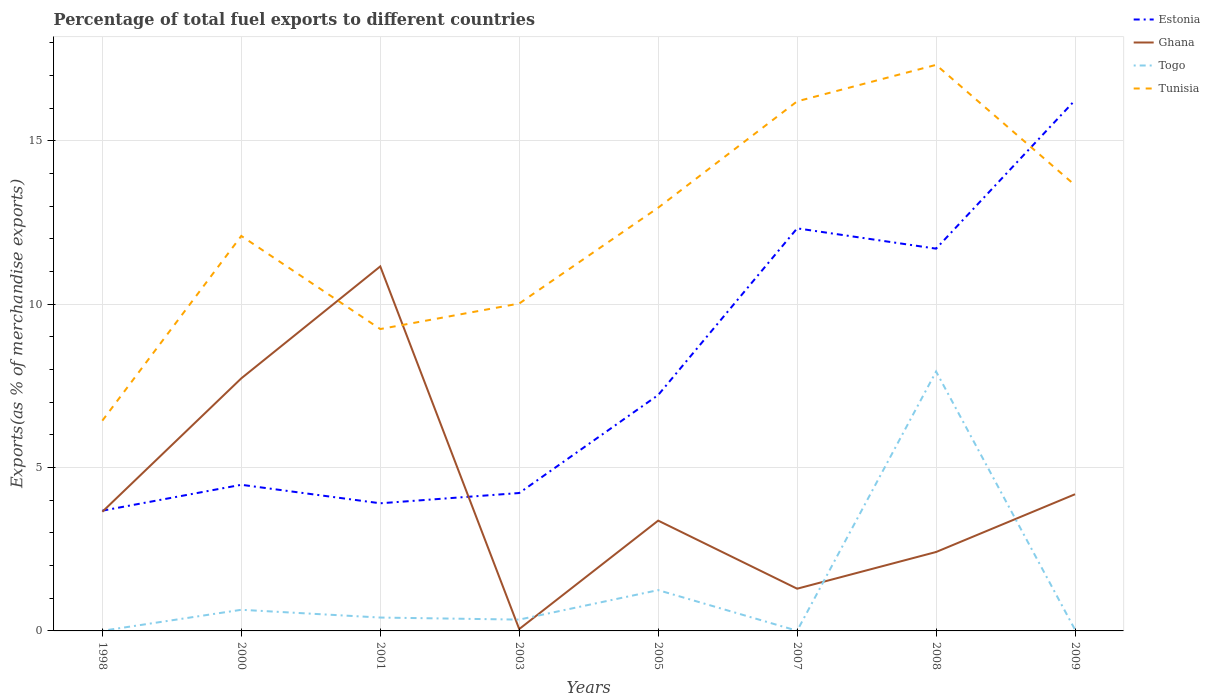How many different coloured lines are there?
Provide a succinct answer. 4. Is the number of lines equal to the number of legend labels?
Your response must be concise. Yes. Across all years, what is the maximum percentage of exports to different countries in Ghana?
Offer a terse response. 0.06. What is the total percentage of exports to different countries in Estonia in the graph?
Keep it short and to the point. -0.54. What is the difference between the highest and the second highest percentage of exports to different countries in Tunisia?
Ensure brevity in your answer.  10.89. What is the difference between the highest and the lowest percentage of exports to different countries in Ghana?
Your answer should be very brief. 2. Is the percentage of exports to different countries in Tunisia strictly greater than the percentage of exports to different countries in Ghana over the years?
Provide a short and direct response. No. How many lines are there?
Keep it short and to the point. 4. How many years are there in the graph?
Make the answer very short. 8. Does the graph contain any zero values?
Your answer should be very brief. No. Does the graph contain grids?
Provide a short and direct response. Yes. Where does the legend appear in the graph?
Offer a terse response. Top right. How many legend labels are there?
Ensure brevity in your answer.  4. How are the legend labels stacked?
Your response must be concise. Vertical. What is the title of the graph?
Your response must be concise. Percentage of total fuel exports to different countries. What is the label or title of the Y-axis?
Offer a very short reply. Exports(as % of merchandise exports). What is the Exports(as % of merchandise exports) in Estonia in 1998?
Provide a short and direct response. 3.68. What is the Exports(as % of merchandise exports) of Ghana in 1998?
Make the answer very short. 3.65. What is the Exports(as % of merchandise exports) in Togo in 1998?
Offer a terse response. 0. What is the Exports(as % of merchandise exports) of Tunisia in 1998?
Ensure brevity in your answer.  6.44. What is the Exports(as % of merchandise exports) in Estonia in 2000?
Offer a terse response. 4.47. What is the Exports(as % of merchandise exports) in Ghana in 2000?
Offer a terse response. 7.73. What is the Exports(as % of merchandise exports) in Togo in 2000?
Ensure brevity in your answer.  0.65. What is the Exports(as % of merchandise exports) of Tunisia in 2000?
Provide a short and direct response. 12.09. What is the Exports(as % of merchandise exports) of Estonia in 2001?
Make the answer very short. 3.91. What is the Exports(as % of merchandise exports) in Ghana in 2001?
Your response must be concise. 11.16. What is the Exports(as % of merchandise exports) of Togo in 2001?
Your answer should be very brief. 0.41. What is the Exports(as % of merchandise exports) in Tunisia in 2001?
Provide a succinct answer. 9.24. What is the Exports(as % of merchandise exports) of Estonia in 2003?
Make the answer very short. 4.22. What is the Exports(as % of merchandise exports) of Ghana in 2003?
Offer a very short reply. 0.06. What is the Exports(as % of merchandise exports) in Togo in 2003?
Keep it short and to the point. 0.35. What is the Exports(as % of merchandise exports) of Tunisia in 2003?
Keep it short and to the point. 10.02. What is the Exports(as % of merchandise exports) in Estonia in 2005?
Your answer should be compact. 7.22. What is the Exports(as % of merchandise exports) in Ghana in 2005?
Ensure brevity in your answer.  3.38. What is the Exports(as % of merchandise exports) in Togo in 2005?
Offer a terse response. 1.25. What is the Exports(as % of merchandise exports) in Tunisia in 2005?
Provide a short and direct response. 12.95. What is the Exports(as % of merchandise exports) in Estonia in 2007?
Provide a short and direct response. 12.32. What is the Exports(as % of merchandise exports) of Ghana in 2007?
Ensure brevity in your answer.  1.29. What is the Exports(as % of merchandise exports) of Togo in 2007?
Provide a short and direct response. 0. What is the Exports(as % of merchandise exports) in Tunisia in 2007?
Ensure brevity in your answer.  16.21. What is the Exports(as % of merchandise exports) in Estonia in 2008?
Offer a very short reply. 11.7. What is the Exports(as % of merchandise exports) of Ghana in 2008?
Your answer should be compact. 2.42. What is the Exports(as % of merchandise exports) in Togo in 2008?
Keep it short and to the point. 7.94. What is the Exports(as % of merchandise exports) in Tunisia in 2008?
Offer a terse response. 17.32. What is the Exports(as % of merchandise exports) of Estonia in 2009?
Provide a succinct answer. 16.24. What is the Exports(as % of merchandise exports) of Ghana in 2009?
Provide a short and direct response. 4.18. What is the Exports(as % of merchandise exports) in Togo in 2009?
Your answer should be compact. 0.04. What is the Exports(as % of merchandise exports) in Tunisia in 2009?
Keep it short and to the point. 13.64. Across all years, what is the maximum Exports(as % of merchandise exports) of Estonia?
Offer a very short reply. 16.24. Across all years, what is the maximum Exports(as % of merchandise exports) of Ghana?
Your answer should be very brief. 11.16. Across all years, what is the maximum Exports(as % of merchandise exports) in Togo?
Ensure brevity in your answer.  7.94. Across all years, what is the maximum Exports(as % of merchandise exports) in Tunisia?
Provide a succinct answer. 17.32. Across all years, what is the minimum Exports(as % of merchandise exports) of Estonia?
Your answer should be very brief. 3.68. Across all years, what is the minimum Exports(as % of merchandise exports) in Ghana?
Keep it short and to the point. 0.06. Across all years, what is the minimum Exports(as % of merchandise exports) in Togo?
Ensure brevity in your answer.  0. Across all years, what is the minimum Exports(as % of merchandise exports) of Tunisia?
Your answer should be very brief. 6.44. What is the total Exports(as % of merchandise exports) in Estonia in the graph?
Make the answer very short. 63.76. What is the total Exports(as % of merchandise exports) in Ghana in the graph?
Provide a short and direct response. 33.86. What is the total Exports(as % of merchandise exports) in Togo in the graph?
Offer a very short reply. 10.63. What is the total Exports(as % of merchandise exports) of Tunisia in the graph?
Make the answer very short. 97.91. What is the difference between the Exports(as % of merchandise exports) of Estonia in 1998 and that in 2000?
Your response must be concise. -0.79. What is the difference between the Exports(as % of merchandise exports) of Ghana in 1998 and that in 2000?
Keep it short and to the point. -4.08. What is the difference between the Exports(as % of merchandise exports) of Togo in 1998 and that in 2000?
Your answer should be very brief. -0.64. What is the difference between the Exports(as % of merchandise exports) in Tunisia in 1998 and that in 2000?
Your response must be concise. -5.65. What is the difference between the Exports(as % of merchandise exports) of Estonia in 1998 and that in 2001?
Your answer should be very brief. -0.23. What is the difference between the Exports(as % of merchandise exports) of Ghana in 1998 and that in 2001?
Ensure brevity in your answer.  -7.51. What is the difference between the Exports(as % of merchandise exports) of Togo in 1998 and that in 2001?
Provide a succinct answer. -0.41. What is the difference between the Exports(as % of merchandise exports) in Tunisia in 1998 and that in 2001?
Your response must be concise. -2.8. What is the difference between the Exports(as % of merchandise exports) in Estonia in 1998 and that in 2003?
Offer a terse response. -0.54. What is the difference between the Exports(as % of merchandise exports) of Ghana in 1998 and that in 2003?
Provide a succinct answer. 3.59. What is the difference between the Exports(as % of merchandise exports) in Togo in 1998 and that in 2003?
Your answer should be very brief. -0.34. What is the difference between the Exports(as % of merchandise exports) in Tunisia in 1998 and that in 2003?
Your answer should be very brief. -3.58. What is the difference between the Exports(as % of merchandise exports) in Estonia in 1998 and that in 2005?
Provide a short and direct response. -3.54. What is the difference between the Exports(as % of merchandise exports) of Ghana in 1998 and that in 2005?
Make the answer very short. 0.27. What is the difference between the Exports(as % of merchandise exports) of Togo in 1998 and that in 2005?
Your response must be concise. -1.24. What is the difference between the Exports(as % of merchandise exports) in Tunisia in 1998 and that in 2005?
Provide a succinct answer. -6.52. What is the difference between the Exports(as % of merchandise exports) of Estonia in 1998 and that in 2007?
Offer a very short reply. -8.64. What is the difference between the Exports(as % of merchandise exports) in Ghana in 1998 and that in 2007?
Provide a succinct answer. 2.35. What is the difference between the Exports(as % of merchandise exports) of Togo in 1998 and that in 2007?
Your response must be concise. -0. What is the difference between the Exports(as % of merchandise exports) of Tunisia in 1998 and that in 2007?
Make the answer very short. -9.77. What is the difference between the Exports(as % of merchandise exports) in Estonia in 1998 and that in 2008?
Offer a terse response. -8.02. What is the difference between the Exports(as % of merchandise exports) in Ghana in 1998 and that in 2008?
Offer a terse response. 1.23. What is the difference between the Exports(as % of merchandise exports) in Togo in 1998 and that in 2008?
Provide a succinct answer. -7.93. What is the difference between the Exports(as % of merchandise exports) in Tunisia in 1998 and that in 2008?
Ensure brevity in your answer.  -10.89. What is the difference between the Exports(as % of merchandise exports) in Estonia in 1998 and that in 2009?
Ensure brevity in your answer.  -12.56. What is the difference between the Exports(as % of merchandise exports) of Ghana in 1998 and that in 2009?
Offer a terse response. -0.54. What is the difference between the Exports(as % of merchandise exports) in Togo in 1998 and that in 2009?
Offer a very short reply. -0.03. What is the difference between the Exports(as % of merchandise exports) in Tunisia in 1998 and that in 2009?
Keep it short and to the point. -7.21. What is the difference between the Exports(as % of merchandise exports) in Estonia in 2000 and that in 2001?
Your response must be concise. 0.57. What is the difference between the Exports(as % of merchandise exports) in Ghana in 2000 and that in 2001?
Ensure brevity in your answer.  -3.43. What is the difference between the Exports(as % of merchandise exports) of Togo in 2000 and that in 2001?
Keep it short and to the point. 0.24. What is the difference between the Exports(as % of merchandise exports) in Tunisia in 2000 and that in 2001?
Offer a very short reply. 2.85. What is the difference between the Exports(as % of merchandise exports) in Estonia in 2000 and that in 2003?
Provide a short and direct response. 0.25. What is the difference between the Exports(as % of merchandise exports) in Ghana in 2000 and that in 2003?
Provide a short and direct response. 7.67. What is the difference between the Exports(as % of merchandise exports) of Togo in 2000 and that in 2003?
Give a very brief answer. 0.3. What is the difference between the Exports(as % of merchandise exports) of Tunisia in 2000 and that in 2003?
Ensure brevity in your answer.  2.07. What is the difference between the Exports(as % of merchandise exports) in Estonia in 2000 and that in 2005?
Give a very brief answer. -2.75. What is the difference between the Exports(as % of merchandise exports) of Ghana in 2000 and that in 2005?
Provide a succinct answer. 4.35. What is the difference between the Exports(as % of merchandise exports) in Togo in 2000 and that in 2005?
Provide a succinct answer. -0.6. What is the difference between the Exports(as % of merchandise exports) in Tunisia in 2000 and that in 2005?
Keep it short and to the point. -0.86. What is the difference between the Exports(as % of merchandise exports) of Estonia in 2000 and that in 2007?
Ensure brevity in your answer.  -7.85. What is the difference between the Exports(as % of merchandise exports) in Ghana in 2000 and that in 2007?
Make the answer very short. 6.44. What is the difference between the Exports(as % of merchandise exports) of Togo in 2000 and that in 2007?
Offer a very short reply. 0.64. What is the difference between the Exports(as % of merchandise exports) in Tunisia in 2000 and that in 2007?
Your response must be concise. -4.12. What is the difference between the Exports(as % of merchandise exports) in Estonia in 2000 and that in 2008?
Provide a short and direct response. -7.23. What is the difference between the Exports(as % of merchandise exports) of Ghana in 2000 and that in 2008?
Make the answer very short. 5.31. What is the difference between the Exports(as % of merchandise exports) of Togo in 2000 and that in 2008?
Offer a terse response. -7.29. What is the difference between the Exports(as % of merchandise exports) of Tunisia in 2000 and that in 2008?
Keep it short and to the point. -5.24. What is the difference between the Exports(as % of merchandise exports) of Estonia in 2000 and that in 2009?
Keep it short and to the point. -11.77. What is the difference between the Exports(as % of merchandise exports) in Ghana in 2000 and that in 2009?
Keep it short and to the point. 3.55. What is the difference between the Exports(as % of merchandise exports) of Togo in 2000 and that in 2009?
Offer a terse response. 0.61. What is the difference between the Exports(as % of merchandise exports) in Tunisia in 2000 and that in 2009?
Provide a short and direct response. -1.55. What is the difference between the Exports(as % of merchandise exports) in Estonia in 2001 and that in 2003?
Provide a short and direct response. -0.31. What is the difference between the Exports(as % of merchandise exports) of Ghana in 2001 and that in 2003?
Ensure brevity in your answer.  11.1. What is the difference between the Exports(as % of merchandise exports) in Togo in 2001 and that in 2003?
Provide a short and direct response. 0.06. What is the difference between the Exports(as % of merchandise exports) in Tunisia in 2001 and that in 2003?
Make the answer very short. -0.78. What is the difference between the Exports(as % of merchandise exports) of Estonia in 2001 and that in 2005?
Offer a terse response. -3.31. What is the difference between the Exports(as % of merchandise exports) in Ghana in 2001 and that in 2005?
Provide a short and direct response. 7.78. What is the difference between the Exports(as % of merchandise exports) in Togo in 2001 and that in 2005?
Keep it short and to the point. -0.84. What is the difference between the Exports(as % of merchandise exports) in Tunisia in 2001 and that in 2005?
Offer a terse response. -3.71. What is the difference between the Exports(as % of merchandise exports) of Estonia in 2001 and that in 2007?
Keep it short and to the point. -8.41. What is the difference between the Exports(as % of merchandise exports) in Ghana in 2001 and that in 2007?
Keep it short and to the point. 9.86. What is the difference between the Exports(as % of merchandise exports) of Togo in 2001 and that in 2007?
Give a very brief answer. 0.4. What is the difference between the Exports(as % of merchandise exports) of Tunisia in 2001 and that in 2007?
Keep it short and to the point. -6.97. What is the difference between the Exports(as % of merchandise exports) of Estonia in 2001 and that in 2008?
Your answer should be very brief. -7.79. What is the difference between the Exports(as % of merchandise exports) of Ghana in 2001 and that in 2008?
Make the answer very short. 8.74. What is the difference between the Exports(as % of merchandise exports) in Togo in 2001 and that in 2008?
Provide a short and direct response. -7.53. What is the difference between the Exports(as % of merchandise exports) of Tunisia in 2001 and that in 2008?
Your answer should be compact. -8.09. What is the difference between the Exports(as % of merchandise exports) of Estonia in 2001 and that in 2009?
Ensure brevity in your answer.  -12.34. What is the difference between the Exports(as % of merchandise exports) in Ghana in 2001 and that in 2009?
Your answer should be compact. 6.97. What is the difference between the Exports(as % of merchandise exports) in Togo in 2001 and that in 2009?
Offer a terse response. 0.37. What is the difference between the Exports(as % of merchandise exports) of Tunisia in 2001 and that in 2009?
Provide a succinct answer. -4.4. What is the difference between the Exports(as % of merchandise exports) in Estonia in 2003 and that in 2005?
Make the answer very short. -3. What is the difference between the Exports(as % of merchandise exports) in Ghana in 2003 and that in 2005?
Your response must be concise. -3.32. What is the difference between the Exports(as % of merchandise exports) in Togo in 2003 and that in 2005?
Your response must be concise. -0.9. What is the difference between the Exports(as % of merchandise exports) in Tunisia in 2003 and that in 2005?
Your answer should be compact. -2.93. What is the difference between the Exports(as % of merchandise exports) of Estonia in 2003 and that in 2007?
Ensure brevity in your answer.  -8.1. What is the difference between the Exports(as % of merchandise exports) of Ghana in 2003 and that in 2007?
Your answer should be very brief. -1.24. What is the difference between the Exports(as % of merchandise exports) in Togo in 2003 and that in 2007?
Offer a terse response. 0.34. What is the difference between the Exports(as % of merchandise exports) of Tunisia in 2003 and that in 2007?
Give a very brief answer. -6.19. What is the difference between the Exports(as % of merchandise exports) of Estonia in 2003 and that in 2008?
Offer a terse response. -7.48. What is the difference between the Exports(as % of merchandise exports) in Ghana in 2003 and that in 2008?
Provide a short and direct response. -2.36. What is the difference between the Exports(as % of merchandise exports) of Togo in 2003 and that in 2008?
Provide a short and direct response. -7.59. What is the difference between the Exports(as % of merchandise exports) in Tunisia in 2003 and that in 2008?
Provide a succinct answer. -7.3. What is the difference between the Exports(as % of merchandise exports) of Estonia in 2003 and that in 2009?
Your response must be concise. -12.02. What is the difference between the Exports(as % of merchandise exports) of Ghana in 2003 and that in 2009?
Your answer should be compact. -4.13. What is the difference between the Exports(as % of merchandise exports) in Togo in 2003 and that in 2009?
Provide a succinct answer. 0.31. What is the difference between the Exports(as % of merchandise exports) of Tunisia in 2003 and that in 2009?
Ensure brevity in your answer.  -3.62. What is the difference between the Exports(as % of merchandise exports) in Estonia in 2005 and that in 2007?
Your response must be concise. -5.1. What is the difference between the Exports(as % of merchandise exports) of Ghana in 2005 and that in 2007?
Provide a short and direct response. 2.08. What is the difference between the Exports(as % of merchandise exports) in Togo in 2005 and that in 2007?
Offer a terse response. 1.24. What is the difference between the Exports(as % of merchandise exports) in Tunisia in 2005 and that in 2007?
Your answer should be compact. -3.26. What is the difference between the Exports(as % of merchandise exports) of Estonia in 2005 and that in 2008?
Give a very brief answer. -4.48. What is the difference between the Exports(as % of merchandise exports) in Ghana in 2005 and that in 2008?
Provide a short and direct response. 0.96. What is the difference between the Exports(as % of merchandise exports) in Togo in 2005 and that in 2008?
Ensure brevity in your answer.  -6.69. What is the difference between the Exports(as % of merchandise exports) of Tunisia in 2005 and that in 2008?
Keep it short and to the point. -4.37. What is the difference between the Exports(as % of merchandise exports) in Estonia in 2005 and that in 2009?
Your answer should be compact. -9.02. What is the difference between the Exports(as % of merchandise exports) of Ghana in 2005 and that in 2009?
Provide a succinct answer. -0.81. What is the difference between the Exports(as % of merchandise exports) in Togo in 2005 and that in 2009?
Keep it short and to the point. 1.21. What is the difference between the Exports(as % of merchandise exports) of Tunisia in 2005 and that in 2009?
Give a very brief answer. -0.69. What is the difference between the Exports(as % of merchandise exports) in Estonia in 2007 and that in 2008?
Keep it short and to the point. 0.62. What is the difference between the Exports(as % of merchandise exports) in Ghana in 2007 and that in 2008?
Ensure brevity in your answer.  -1.12. What is the difference between the Exports(as % of merchandise exports) in Togo in 2007 and that in 2008?
Ensure brevity in your answer.  -7.93. What is the difference between the Exports(as % of merchandise exports) of Tunisia in 2007 and that in 2008?
Your response must be concise. -1.12. What is the difference between the Exports(as % of merchandise exports) in Estonia in 2007 and that in 2009?
Make the answer very short. -3.92. What is the difference between the Exports(as % of merchandise exports) of Ghana in 2007 and that in 2009?
Make the answer very short. -2.89. What is the difference between the Exports(as % of merchandise exports) of Togo in 2007 and that in 2009?
Provide a short and direct response. -0.03. What is the difference between the Exports(as % of merchandise exports) of Tunisia in 2007 and that in 2009?
Make the answer very short. 2.57. What is the difference between the Exports(as % of merchandise exports) in Estonia in 2008 and that in 2009?
Offer a terse response. -4.54. What is the difference between the Exports(as % of merchandise exports) of Ghana in 2008 and that in 2009?
Make the answer very short. -1.77. What is the difference between the Exports(as % of merchandise exports) of Togo in 2008 and that in 2009?
Your response must be concise. 7.9. What is the difference between the Exports(as % of merchandise exports) in Tunisia in 2008 and that in 2009?
Offer a very short reply. 3.68. What is the difference between the Exports(as % of merchandise exports) in Estonia in 1998 and the Exports(as % of merchandise exports) in Ghana in 2000?
Your answer should be compact. -4.05. What is the difference between the Exports(as % of merchandise exports) of Estonia in 1998 and the Exports(as % of merchandise exports) of Togo in 2000?
Provide a succinct answer. 3.03. What is the difference between the Exports(as % of merchandise exports) in Estonia in 1998 and the Exports(as % of merchandise exports) in Tunisia in 2000?
Provide a succinct answer. -8.41. What is the difference between the Exports(as % of merchandise exports) in Ghana in 1998 and the Exports(as % of merchandise exports) in Togo in 2000?
Your answer should be compact. 3. What is the difference between the Exports(as % of merchandise exports) of Ghana in 1998 and the Exports(as % of merchandise exports) of Tunisia in 2000?
Offer a very short reply. -8.44. What is the difference between the Exports(as % of merchandise exports) in Togo in 1998 and the Exports(as % of merchandise exports) in Tunisia in 2000?
Give a very brief answer. -12.08. What is the difference between the Exports(as % of merchandise exports) in Estonia in 1998 and the Exports(as % of merchandise exports) in Ghana in 2001?
Make the answer very short. -7.48. What is the difference between the Exports(as % of merchandise exports) in Estonia in 1998 and the Exports(as % of merchandise exports) in Togo in 2001?
Offer a very short reply. 3.27. What is the difference between the Exports(as % of merchandise exports) in Estonia in 1998 and the Exports(as % of merchandise exports) in Tunisia in 2001?
Your answer should be very brief. -5.56. What is the difference between the Exports(as % of merchandise exports) of Ghana in 1998 and the Exports(as % of merchandise exports) of Togo in 2001?
Give a very brief answer. 3.24. What is the difference between the Exports(as % of merchandise exports) in Ghana in 1998 and the Exports(as % of merchandise exports) in Tunisia in 2001?
Your answer should be very brief. -5.59. What is the difference between the Exports(as % of merchandise exports) in Togo in 1998 and the Exports(as % of merchandise exports) in Tunisia in 2001?
Give a very brief answer. -9.23. What is the difference between the Exports(as % of merchandise exports) of Estonia in 1998 and the Exports(as % of merchandise exports) of Ghana in 2003?
Keep it short and to the point. 3.62. What is the difference between the Exports(as % of merchandise exports) in Estonia in 1998 and the Exports(as % of merchandise exports) in Togo in 2003?
Give a very brief answer. 3.33. What is the difference between the Exports(as % of merchandise exports) of Estonia in 1998 and the Exports(as % of merchandise exports) of Tunisia in 2003?
Make the answer very short. -6.34. What is the difference between the Exports(as % of merchandise exports) in Ghana in 1998 and the Exports(as % of merchandise exports) in Togo in 2003?
Offer a terse response. 3.3. What is the difference between the Exports(as % of merchandise exports) in Ghana in 1998 and the Exports(as % of merchandise exports) in Tunisia in 2003?
Provide a short and direct response. -6.37. What is the difference between the Exports(as % of merchandise exports) in Togo in 1998 and the Exports(as % of merchandise exports) in Tunisia in 2003?
Provide a short and direct response. -10.02. What is the difference between the Exports(as % of merchandise exports) in Estonia in 1998 and the Exports(as % of merchandise exports) in Ghana in 2005?
Your answer should be compact. 0.3. What is the difference between the Exports(as % of merchandise exports) in Estonia in 1998 and the Exports(as % of merchandise exports) in Togo in 2005?
Keep it short and to the point. 2.43. What is the difference between the Exports(as % of merchandise exports) of Estonia in 1998 and the Exports(as % of merchandise exports) of Tunisia in 2005?
Offer a very short reply. -9.27. What is the difference between the Exports(as % of merchandise exports) in Ghana in 1998 and the Exports(as % of merchandise exports) in Togo in 2005?
Offer a very short reply. 2.4. What is the difference between the Exports(as % of merchandise exports) in Ghana in 1998 and the Exports(as % of merchandise exports) in Tunisia in 2005?
Your response must be concise. -9.31. What is the difference between the Exports(as % of merchandise exports) of Togo in 1998 and the Exports(as % of merchandise exports) of Tunisia in 2005?
Keep it short and to the point. -12.95. What is the difference between the Exports(as % of merchandise exports) in Estonia in 1998 and the Exports(as % of merchandise exports) in Ghana in 2007?
Keep it short and to the point. 2.39. What is the difference between the Exports(as % of merchandise exports) of Estonia in 1998 and the Exports(as % of merchandise exports) of Togo in 2007?
Provide a succinct answer. 3.68. What is the difference between the Exports(as % of merchandise exports) in Estonia in 1998 and the Exports(as % of merchandise exports) in Tunisia in 2007?
Your answer should be very brief. -12.53. What is the difference between the Exports(as % of merchandise exports) of Ghana in 1998 and the Exports(as % of merchandise exports) of Togo in 2007?
Offer a very short reply. 3.64. What is the difference between the Exports(as % of merchandise exports) of Ghana in 1998 and the Exports(as % of merchandise exports) of Tunisia in 2007?
Offer a terse response. -12.56. What is the difference between the Exports(as % of merchandise exports) in Togo in 1998 and the Exports(as % of merchandise exports) in Tunisia in 2007?
Give a very brief answer. -16.2. What is the difference between the Exports(as % of merchandise exports) of Estonia in 1998 and the Exports(as % of merchandise exports) of Ghana in 2008?
Keep it short and to the point. 1.26. What is the difference between the Exports(as % of merchandise exports) in Estonia in 1998 and the Exports(as % of merchandise exports) in Togo in 2008?
Provide a short and direct response. -4.26. What is the difference between the Exports(as % of merchandise exports) of Estonia in 1998 and the Exports(as % of merchandise exports) of Tunisia in 2008?
Provide a succinct answer. -13.64. What is the difference between the Exports(as % of merchandise exports) of Ghana in 1998 and the Exports(as % of merchandise exports) of Togo in 2008?
Your answer should be very brief. -4.29. What is the difference between the Exports(as % of merchandise exports) in Ghana in 1998 and the Exports(as % of merchandise exports) in Tunisia in 2008?
Your answer should be compact. -13.68. What is the difference between the Exports(as % of merchandise exports) in Togo in 1998 and the Exports(as % of merchandise exports) in Tunisia in 2008?
Ensure brevity in your answer.  -17.32. What is the difference between the Exports(as % of merchandise exports) in Estonia in 1998 and the Exports(as % of merchandise exports) in Ghana in 2009?
Your answer should be compact. -0.5. What is the difference between the Exports(as % of merchandise exports) of Estonia in 1998 and the Exports(as % of merchandise exports) of Togo in 2009?
Ensure brevity in your answer.  3.64. What is the difference between the Exports(as % of merchandise exports) of Estonia in 1998 and the Exports(as % of merchandise exports) of Tunisia in 2009?
Keep it short and to the point. -9.96. What is the difference between the Exports(as % of merchandise exports) of Ghana in 1998 and the Exports(as % of merchandise exports) of Togo in 2009?
Make the answer very short. 3.61. What is the difference between the Exports(as % of merchandise exports) of Ghana in 1998 and the Exports(as % of merchandise exports) of Tunisia in 2009?
Provide a succinct answer. -9.99. What is the difference between the Exports(as % of merchandise exports) in Togo in 1998 and the Exports(as % of merchandise exports) in Tunisia in 2009?
Your response must be concise. -13.64. What is the difference between the Exports(as % of merchandise exports) in Estonia in 2000 and the Exports(as % of merchandise exports) in Ghana in 2001?
Provide a succinct answer. -6.68. What is the difference between the Exports(as % of merchandise exports) in Estonia in 2000 and the Exports(as % of merchandise exports) in Togo in 2001?
Give a very brief answer. 4.06. What is the difference between the Exports(as % of merchandise exports) in Estonia in 2000 and the Exports(as % of merchandise exports) in Tunisia in 2001?
Provide a short and direct response. -4.77. What is the difference between the Exports(as % of merchandise exports) of Ghana in 2000 and the Exports(as % of merchandise exports) of Togo in 2001?
Provide a succinct answer. 7.32. What is the difference between the Exports(as % of merchandise exports) of Ghana in 2000 and the Exports(as % of merchandise exports) of Tunisia in 2001?
Ensure brevity in your answer.  -1.51. What is the difference between the Exports(as % of merchandise exports) in Togo in 2000 and the Exports(as % of merchandise exports) in Tunisia in 2001?
Make the answer very short. -8.59. What is the difference between the Exports(as % of merchandise exports) in Estonia in 2000 and the Exports(as % of merchandise exports) in Ghana in 2003?
Give a very brief answer. 4.42. What is the difference between the Exports(as % of merchandise exports) in Estonia in 2000 and the Exports(as % of merchandise exports) in Togo in 2003?
Your answer should be very brief. 4.13. What is the difference between the Exports(as % of merchandise exports) of Estonia in 2000 and the Exports(as % of merchandise exports) of Tunisia in 2003?
Your response must be concise. -5.55. What is the difference between the Exports(as % of merchandise exports) of Ghana in 2000 and the Exports(as % of merchandise exports) of Togo in 2003?
Your answer should be compact. 7.38. What is the difference between the Exports(as % of merchandise exports) in Ghana in 2000 and the Exports(as % of merchandise exports) in Tunisia in 2003?
Your response must be concise. -2.29. What is the difference between the Exports(as % of merchandise exports) of Togo in 2000 and the Exports(as % of merchandise exports) of Tunisia in 2003?
Make the answer very short. -9.37. What is the difference between the Exports(as % of merchandise exports) in Estonia in 2000 and the Exports(as % of merchandise exports) in Ghana in 2005?
Offer a very short reply. 1.1. What is the difference between the Exports(as % of merchandise exports) in Estonia in 2000 and the Exports(as % of merchandise exports) in Togo in 2005?
Your response must be concise. 3.22. What is the difference between the Exports(as % of merchandise exports) in Estonia in 2000 and the Exports(as % of merchandise exports) in Tunisia in 2005?
Provide a short and direct response. -8.48. What is the difference between the Exports(as % of merchandise exports) of Ghana in 2000 and the Exports(as % of merchandise exports) of Togo in 2005?
Your answer should be compact. 6.48. What is the difference between the Exports(as % of merchandise exports) of Ghana in 2000 and the Exports(as % of merchandise exports) of Tunisia in 2005?
Give a very brief answer. -5.22. What is the difference between the Exports(as % of merchandise exports) in Togo in 2000 and the Exports(as % of merchandise exports) in Tunisia in 2005?
Ensure brevity in your answer.  -12.31. What is the difference between the Exports(as % of merchandise exports) in Estonia in 2000 and the Exports(as % of merchandise exports) in Ghana in 2007?
Keep it short and to the point. 3.18. What is the difference between the Exports(as % of merchandise exports) of Estonia in 2000 and the Exports(as % of merchandise exports) of Togo in 2007?
Your answer should be very brief. 4.47. What is the difference between the Exports(as % of merchandise exports) of Estonia in 2000 and the Exports(as % of merchandise exports) of Tunisia in 2007?
Keep it short and to the point. -11.74. What is the difference between the Exports(as % of merchandise exports) of Ghana in 2000 and the Exports(as % of merchandise exports) of Togo in 2007?
Make the answer very short. 7.73. What is the difference between the Exports(as % of merchandise exports) in Ghana in 2000 and the Exports(as % of merchandise exports) in Tunisia in 2007?
Offer a terse response. -8.48. What is the difference between the Exports(as % of merchandise exports) in Togo in 2000 and the Exports(as % of merchandise exports) in Tunisia in 2007?
Keep it short and to the point. -15.56. What is the difference between the Exports(as % of merchandise exports) in Estonia in 2000 and the Exports(as % of merchandise exports) in Ghana in 2008?
Provide a succinct answer. 2.06. What is the difference between the Exports(as % of merchandise exports) in Estonia in 2000 and the Exports(as % of merchandise exports) in Togo in 2008?
Your answer should be very brief. -3.47. What is the difference between the Exports(as % of merchandise exports) of Estonia in 2000 and the Exports(as % of merchandise exports) of Tunisia in 2008?
Offer a terse response. -12.85. What is the difference between the Exports(as % of merchandise exports) of Ghana in 2000 and the Exports(as % of merchandise exports) of Togo in 2008?
Ensure brevity in your answer.  -0.21. What is the difference between the Exports(as % of merchandise exports) in Ghana in 2000 and the Exports(as % of merchandise exports) in Tunisia in 2008?
Your answer should be compact. -9.59. What is the difference between the Exports(as % of merchandise exports) in Togo in 2000 and the Exports(as % of merchandise exports) in Tunisia in 2008?
Make the answer very short. -16.68. What is the difference between the Exports(as % of merchandise exports) in Estonia in 2000 and the Exports(as % of merchandise exports) in Ghana in 2009?
Offer a very short reply. 0.29. What is the difference between the Exports(as % of merchandise exports) in Estonia in 2000 and the Exports(as % of merchandise exports) in Togo in 2009?
Offer a very short reply. 4.44. What is the difference between the Exports(as % of merchandise exports) in Estonia in 2000 and the Exports(as % of merchandise exports) in Tunisia in 2009?
Make the answer very short. -9.17. What is the difference between the Exports(as % of merchandise exports) of Ghana in 2000 and the Exports(as % of merchandise exports) of Togo in 2009?
Keep it short and to the point. 7.69. What is the difference between the Exports(as % of merchandise exports) of Ghana in 2000 and the Exports(as % of merchandise exports) of Tunisia in 2009?
Make the answer very short. -5.91. What is the difference between the Exports(as % of merchandise exports) in Togo in 2000 and the Exports(as % of merchandise exports) in Tunisia in 2009?
Your response must be concise. -12.99. What is the difference between the Exports(as % of merchandise exports) in Estonia in 2001 and the Exports(as % of merchandise exports) in Ghana in 2003?
Offer a terse response. 3.85. What is the difference between the Exports(as % of merchandise exports) of Estonia in 2001 and the Exports(as % of merchandise exports) of Togo in 2003?
Your answer should be very brief. 3.56. What is the difference between the Exports(as % of merchandise exports) of Estonia in 2001 and the Exports(as % of merchandise exports) of Tunisia in 2003?
Make the answer very short. -6.11. What is the difference between the Exports(as % of merchandise exports) of Ghana in 2001 and the Exports(as % of merchandise exports) of Togo in 2003?
Keep it short and to the point. 10.81. What is the difference between the Exports(as % of merchandise exports) of Ghana in 2001 and the Exports(as % of merchandise exports) of Tunisia in 2003?
Your answer should be very brief. 1.14. What is the difference between the Exports(as % of merchandise exports) in Togo in 2001 and the Exports(as % of merchandise exports) in Tunisia in 2003?
Offer a terse response. -9.61. What is the difference between the Exports(as % of merchandise exports) of Estonia in 2001 and the Exports(as % of merchandise exports) of Ghana in 2005?
Your answer should be very brief. 0.53. What is the difference between the Exports(as % of merchandise exports) in Estonia in 2001 and the Exports(as % of merchandise exports) in Togo in 2005?
Your answer should be compact. 2.66. What is the difference between the Exports(as % of merchandise exports) of Estonia in 2001 and the Exports(as % of merchandise exports) of Tunisia in 2005?
Provide a short and direct response. -9.05. What is the difference between the Exports(as % of merchandise exports) in Ghana in 2001 and the Exports(as % of merchandise exports) in Togo in 2005?
Offer a terse response. 9.91. What is the difference between the Exports(as % of merchandise exports) of Ghana in 2001 and the Exports(as % of merchandise exports) of Tunisia in 2005?
Provide a short and direct response. -1.8. What is the difference between the Exports(as % of merchandise exports) in Togo in 2001 and the Exports(as % of merchandise exports) in Tunisia in 2005?
Your response must be concise. -12.54. What is the difference between the Exports(as % of merchandise exports) in Estonia in 2001 and the Exports(as % of merchandise exports) in Ghana in 2007?
Make the answer very short. 2.61. What is the difference between the Exports(as % of merchandise exports) of Estonia in 2001 and the Exports(as % of merchandise exports) of Togo in 2007?
Give a very brief answer. 3.9. What is the difference between the Exports(as % of merchandise exports) in Estonia in 2001 and the Exports(as % of merchandise exports) in Tunisia in 2007?
Give a very brief answer. -12.3. What is the difference between the Exports(as % of merchandise exports) of Ghana in 2001 and the Exports(as % of merchandise exports) of Togo in 2007?
Ensure brevity in your answer.  11.15. What is the difference between the Exports(as % of merchandise exports) of Ghana in 2001 and the Exports(as % of merchandise exports) of Tunisia in 2007?
Your answer should be compact. -5.05. What is the difference between the Exports(as % of merchandise exports) in Togo in 2001 and the Exports(as % of merchandise exports) in Tunisia in 2007?
Your response must be concise. -15.8. What is the difference between the Exports(as % of merchandise exports) of Estonia in 2001 and the Exports(as % of merchandise exports) of Ghana in 2008?
Your answer should be compact. 1.49. What is the difference between the Exports(as % of merchandise exports) in Estonia in 2001 and the Exports(as % of merchandise exports) in Togo in 2008?
Your response must be concise. -4.03. What is the difference between the Exports(as % of merchandise exports) in Estonia in 2001 and the Exports(as % of merchandise exports) in Tunisia in 2008?
Your answer should be compact. -13.42. What is the difference between the Exports(as % of merchandise exports) in Ghana in 2001 and the Exports(as % of merchandise exports) in Togo in 2008?
Offer a terse response. 3.22. What is the difference between the Exports(as % of merchandise exports) of Ghana in 2001 and the Exports(as % of merchandise exports) of Tunisia in 2008?
Keep it short and to the point. -6.17. What is the difference between the Exports(as % of merchandise exports) of Togo in 2001 and the Exports(as % of merchandise exports) of Tunisia in 2008?
Your response must be concise. -16.91. What is the difference between the Exports(as % of merchandise exports) of Estonia in 2001 and the Exports(as % of merchandise exports) of Ghana in 2009?
Offer a terse response. -0.28. What is the difference between the Exports(as % of merchandise exports) in Estonia in 2001 and the Exports(as % of merchandise exports) in Togo in 2009?
Make the answer very short. 3.87. What is the difference between the Exports(as % of merchandise exports) of Estonia in 2001 and the Exports(as % of merchandise exports) of Tunisia in 2009?
Keep it short and to the point. -9.73. What is the difference between the Exports(as % of merchandise exports) in Ghana in 2001 and the Exports(as % of merchandise exports) in Togo in 2009?
Provide a short and direct response. 11.12. What is the difference between the Exports(as % of merchandise exports) in Ghana in 2001 and the Exports(as % of merchandise exports) in Tunisia in 2009?
Ensure brevity in your answer.  -2.48. What is the difference between the Exports(as % of merchandise exports) of Togo in 2001 and the Exports(as % of merchandise exports) of Tunisia in 2009?
Your answer should be compact. -13.23. What is the difference between the Exports(as % of merchandise exports) of Estonia in 2003 and the Exports(as % of merchandise exports) of Ghana in 2005?
Ensure brevity in your answer.  0.84. What is the difference between the Exports(as % of merchandise exports) of Estonia in 2003 and the Exports(as % of merchandise exports) of Togo in 2005?
Offer a terse response. 2.97. What is the difference between the Exports(as % of merchandise exports) in Estonia in 2003 and the Exports(as % of merchandise exports) in Tunisia in 2005?
Your answer should be compact. -8.73. What is the difference between the Exports(as % of merchandise exports) in Ghana in 2003 and the Exports(as % of merchandise exports) in Togo in 2005?
Make the answer very short. -1.19. What is the difference between the Exports(as % of merchandise exports) in Ghana in 2003 and the Exports(as % of merchandise exports) in Tunisia in 2005?
Give a very brief answer. -12.9. What is the difference between the Exports(as % of merchandise exports) in Togo in 2003 and the Exports(as % of merchandise exports) in Tunisia in 2005?
Offer a very short reply. -12.61. What is the difference between the Exports(as % of merchandise exports) of Estonia in 2003 and the Exports(as % of merchandise exports) of Ghana in 2007?
Ensure brevity in your answer.  2.93. What is the difference between the Exports(as % of merchandise exports) of Estonia in 2003 and the Exports(as % of merchandise exports) of Togo in 2007?
Your answer should be very brief. 4.22. What is the difference between the Exports(as % of merchandise exports) in Estonia in 2003 and the Exports(as % of merchandise exports) in Tunisia in 2007?
Keep it short and to the point. -11.99. What is the difference between the Exports(as % of merchandise exports) of Ghana in 2003 and the Exports(as % of merchandise exports) of Togo in 2007?
Your answer should be compact. 0.05. What is the difference between the Exports(as % of merchandise exports) in Ghana in 2003 and the Exports(as % of merchandise exports) in Tunisia in 2007?
Your answer should be very brief. -16.15. What is the difference between the Exports(as % of merchandise exports) of Togo in 2003 and the Exports(as % of merchandise exports) of Tunisia in 2007?
Make the answer very short. -15.86. What is the difference between the Exports(as % of merchandise exports) of Estonia in 2003 and the Exports(as % of merchandise exports) of Ghana in 2008?
Offer a very short reply. 1.81. What is the difference between the Exports(as % of merchandise exports) of Estonia in 2003 and the Exports(as % of merchandise exports) of Togo in 2008?
Your answer should be compact. -3.72. What is the difference between the Exports(as % of merchandise exports) of Estonia in 2003 and the Exports(as % of merchandise exports) of Tunisia in 2008?
Provide a short and direct response. -13.1. What is the difference between the Exports(as % of merchandise exports) in Ghana in 2003 and the Exports(as % of merchandise exports) in Togo in 2008?
Provide a succinct answer. -7.88. What is the difference between the Exports(as % of merchandise exports) in Ghana in 2003 and the Exports(as % of merchandise exports) in Tunisia in 2008?
Provide a succinct answer. -17.27. What is the difference between the Exports(as % of merchandise exports) of Togo in 2003 and the Exports(as % of merchandise exports) of Tunisia in 2008?
Your answer should be compact. -16.98. What is the difference between the Exports(as % of merchandise exports) in Estonia in 2003 and the Exports(as % of merchandise exports) in Ghana in 2009?
Provide a succinct answer. 0.04. What is the difference between the Exports(as % of merchandise exports) of Estonia in 2003 and the Exports(as % of merchandise exports) of Togo in 2009?
Your answer should be very brief. 4.18. What is the difference between the Exports(as % of merchandise exports) in Estonia in 2003 and the Exports(as % of merchandise exports) in Tunisia in 2009?
Provide a succinct answer. -9.42. What is the difference between the Exports(as % of merchandise exports) in Ghana in 2003 and the Exports(as % of merchandise exports) in Togo in 2009?
Ensure brevity in your answer.  0.02. What is the difference between the Exports(as % of merchandise exports) in Ghana in 2003 and the Exports(as % of merchandise exports) in Tunisia in 2009?
Make the answer very short. -13.58. What is the difference between the Exports(as % of merchandise exports) in Togo in 2003 and the Exports(as % of merchandise exports) in Tunisia in 2009?
Your answer should be compact. -13.29. What is the difference between the Exports(as % of merchandise exports) in Estonia in 2005 and the Exports(as % of merchandise exports) in Ghana in 2007?
Provide a short and direct response. 5.93. What is the difference between the Exports(as % of merchandise exports) of Estonia in 2005 and the Exports(as % of merchandise exports) of Togo in 2007?
Make the answer very short. 7.21. What is the difference between the Exports(as % of merchandise exports) in Estonia in 2005 and the Exports(as % of merchandise exports) in Tunisia in 2007?
Make the answer very short. -8.99. What is the difference between the Exports(as % of merchandise exports) in Ghana in 2005 and the Exports(as % of merchandise exports) in Togo in 2007?
Your answer should be very brief. 3.37. What is the difference between the Exports(as % of merchandise exports) of Ghana in 2005 and the Exports(as % of merchandise exports) of Tunisia in 2007?
Provide a succinct answer. -12.83. What is the difference between the Exports(as % of merchandise exports) of Togo in 2005 and the Exports(as % of merchandise exports) of Tunisia in 2007?
Offer a very short reply. -14.96. What is the difference between the Exports(as % of merchandise exports) of Estonia in 2005 and the Exports(as % of merchandise exports) of Ghana in 2008?
Ensure brevity in your answer.  4.8. What is the difference between the Exports(as % of merchandise exports) in Estonia in 2005 and the Exports(as % of merchandise exports) in Togo in 2008?
Make the answer very short. -0.72. What is the difference between the Exports(as % of merchandise exports) in Estonia in 2005 and the Exports(as % of merchandise exports) in Tunisia in 2008?
Give a very brief answer. -10.1. What is the difference between the Exports(as % of merchandise exports) in Ghana in 2005 and the Exports(as % of merchandise exports) in Togo in 2008?
Your answer should be very brief. -4.56. What is the difference between the Exports(as % of merchandise exports) of Ghana in 2005 and the Exports(as % of merchandise exports) of Tunisia in 2008?
Provide a succinct answer. -13.95. What is the difference between the Exports(as % of merchandise exports) in Togo in 2005 and the Exports(as % of merchandise exports) in Tunisia in 2008?
Your answer should be very brief. -16.08. What is the difference between the Exports(as % of merchandise exports) in Estonia in 2005 and the Exports(as % of merchandise exports) in Ghana in 2009?
Keep it short and to the point. 3.04. What is the difference between the Exports(as % of merchandise exports) of Estonia in 2005 and the Exports(as % of merchandise exports) of Togo in 2009?
Provide a succinct answer. 7.18. What is the difference between the Exports(as % of merchandise exports) in Estonia in 2005 and the Exports(as % of merchandise exports) in Tunisia in 2009?
Make the answer very short. -6.42. What is the difference between the Exports(as % of merchandise exports) in Ghana in 2005 and the Exports(as % of merchandise exports) in Togo in 2009?
Ensure brevity in your answer.  3.34. What is the difference between the Exports(as % of merchandise exports) of Ghana in 2005 and the Exports(as % of merchandise exports) of Tunisia in 2009?
Offer a very short reply. -10.26. What is the difference between the Exports(as % of merchandise exports) of Togo in 2005 and the Exports(as % of merchandise exports) of Tunisia in 2009?
Keep it short and to the point. -12.39. What is the difference between the Exports(as % of merchandise exports) in Estonia in 2007 and the Exports(as % of merchandise exports) in Ghana in 2008?
Give a very brief answer. 9.91. What is the difference between the Exports(as % of merchandise exports) of Estonia in 2007 and the Exports(as % of merchandise exports) of Togo in 2008?
Give a very brief answer. 4.38. What is the difference between the Exports(as % of merchandise exports) of Estonia in 2007 and the Exports(as % of merchandise exports) of Tunisia in 2008?
Ensure brevity in your answer.  -5. What is the difference between the Exports(as % of merchandise exports) in Ghana in 2007 and the Exports(as % of merchandise exports) in Togo in 2008?
Your response must be concise. -6.65. What is the difference between the Exports(as % of merchandise exports) in Ghana in 2007 and the Exports(as % of merchandise exports) in Tunisia in 2008?
Ensure brevity in your answer.  -16.03. What is the difference between the Exports(as % of merchandise exports) of Togo in 2007 and the Exports(as % of merchandise exports) of Tunisia in 2008?
Your answer should be very brief. -17.32. What is the difference between the Exports(as % of merchandise exports) of Estonia in 2007 and the Exports(as % of merchandise exports) of Ghana in 2009?
Your answer should be very brief. 8.14. What is the difference between the Exports(as % of merchandise exports) of Estonia in 2007 and the Exports(as % of merchandise exports) of Togo in 2009?
Provide a succinct answer. 12.29. What is the difference between the Exports(as % of merchandise exports) in Estonia in 2007 and the Exports(as % of merchandise exports) in Tunisia in 2009?
Your answer should be compact. -1.32. What is the difference between the Exports(as % of merchandise exports) in Ghana in 2007 and the Exports(as % of merchandise exports) in Togo in 2009?
Your response must be concise. 1.26. What is the difference between the Exports(as % of merchandise exports) of Ghana in 2007 and the Exports(as % of merchandise exports) of Tunisia in 2009?
Keep it short and to the point. -12.35. What is the difference between the Exports(as % of merchandise exports) in Togo in 2007 and the Exports(as % of merchandise exports) in Tunisia in 2009?
Provide a succinct answer. -13.64. What is the difference between the Exports(as % of merchandise exports) of Estonia in 2008 and the Exports(as % of merchandise exports) of Ghana in 2009?
Make the answer very short. 7.52. What is the difference between the Exports(as % of merchandise exports) of Estonia in 2008 and the Exports(as % of merchandise exports) of Togo in 2009?
Your answer should be very brief. 11.66. What is the difference between the Exports(as % of merchandise exports) of Estonia in 2008 and the Exports(as % of merchandise exports) of Tunisia in 2009?
Make the answer very short. -1.94. What is the difference between the Exports(as % of merchandise exports) in Ghana in 2008 and the Exports(as % of merchandise exports) in Togo in 2009?
Provide a short and direct response. 2.38. What is the difference between the Exports(as % of merchandise exports) in Ghana in 2008 and the Exports(as % of merchandise exports) in Tunisia in 2009?
Provide a short and direct response. -11.23. What is the difference between the Exports(as % of merchandise exports) in Togo in 2008 and the Exports(as % of merchandise exports) in Tunisia in 2009?
Your response must be concise. -5.7. What is the average Exports(as % of merchandise exports) of Estonia per year?
Keep it short and to the point. 7.97. What is the average Exports(as % of merchandise exports) of Ghana per year?
Offer a terse response. 4.23. What is the average Exports(as % of merchandise exports) of Togo per year?
Your response must be concise. 1.33. What is the average Exports(as % of merchandise exports) in Tunisia per year?
Offer a terse response. 12.24. In the year 1998, what is the difference between the Exports(as % of merchandise exports) in Estonia and Exports(as % of merchandise exports) in Ghana?
Provide a succinct answer. 0.03. In the year 1998, what is the difference between the Exports(as % of merchandise exports) in Estonia and Exports(as % of merchandise exports) in Togo?
Your response must be concise. 3.68. In the year 1998, what is the difference between the Exports(as % of merchandise exports) in Estonia and Exports(as % of merchandise exports) in Tunisia?
Provide a succinct answer. -2.76. In the year 1998, what is the difference between the Exports(as % of merchandise exports) of Ghana and Exports(as % of merchandise exports) of Togo?
Your answer should be compact. 3.64. In the year 1998, what is the difference between the Exports(as % of merchandise exports) in Ghana and Exports(as % of merchandise exports) in Tunisia?
Ensure brevity in your answer.  -2.79. In the year 1998, what is the difference between the Exports(as % of merchandise exports) in Togo and Exports(as % of merchandise exports) in Tunisia?
Your answer should be compact. -6.43. In the year 2000, what is the difference between the Exports(as % of merchandise exports) in Estonia and Exports(as % of merchandise exports) in Ghana?
Your answer should be very brief. -3.26. In the year 2000, what is the difference between the Exports(as % of merchandise exports) of Estonia and Exports(as % of merchandise exports) of Togo?
Provide a succinct answer. 3.83. In the year 2000, what is the difference between the Exports(as % of merchandise exports) in Estonia and Exports(as % of merchandise exports) in Tunisia?
Give a very brief answer. -7.62. In the year 2000, what is the difference between the Exports(as % of merchandise exports) in Ghana and Exports(as % of merchandise exports) in Togo?
Provide a succinct answer. 7.08. In the year 2000, what is the difference between the Exports(as % of merchandise exports) of Ghana and Exports(as % of merchandise exports) of Tunisia?
Your answer should be very brief. -4.36. In the year 2000, what is the difference between the Exports(as % of merchandise exports) of Togo and Exports(as % of merchandise exports) of Tunisia?
Your response must be concise. -11.44. In the year 2001, what is the difference between the Exports(as % of merchandise exports) in Estonia and Exports(as % of merchandise exports) in Ghana?
Your response must be concise. -7.25. In the year 2001, what is the difference between the Exports(as % of merchandise exports) of Estonia and Exports(as % of merchandise exports) of Togo?
Provide a succinct answer. 3.5. In the year 2001, what is the difference between the Exports(as % of merchandise exports) of Estonia and Exports(as % of merchandise exports) of Tunisia?
Provide a succinct answer. -5.33. In the year 2001, what is the difference between the Exports(as % of merchandise exports) in Ghana and Exports(as % of merchandise exports) in Togo?
Give a very brief answer. 10.75. In the year 2001, what is the difference between the Exports(as % of merchandise exports) in Ghana and Exports(as % of merchandise exports) in Tunisia?
Provide a short and direct response. 1.92. In the year 2001, what is the difference between the Exports(as % of merchandise exports) in Togo and Exports(as % of merchandise exports) in Tunisia?
Offer a very short reply. -8.83. In the year 2003, what is the difference between the Exports(as % of merchandise exports) in Estonia and Exports(as % of merchandise exports) in Ghana?
Provide a short and direct response. 4.16. In the year 2003, what is the difference between the Exports(as % of merchandise exports) of Estonia and Exports(as % of merchandise exports) of Togo?
Offer a terse response. 3.87. In the year 2003, what is the difference between the Exports(as % of merchandise exports) in Estonia and Exports(as % of merchandise exports) in Tunisia?
Give a very brief answer. -5.8. In the year 2003, what is the difference between the Exports(as % of merchandise exports) of Ghana and Exports(as % of merchandise exports) of Togo?
Give a very brief answer. -0.29. In the year 2003, what is the difference between the Exports(as % of merchandise exports) in Ghana and Exports(as % of merchandise exports) in Tunisia?
Provide a short and direct response. -9.96. In the year 2003, what is the difference between the Exports(as % of merchandise exports) of Togo and Exports(as % of merchandise exports) of Tunisia?
Make the answer very short. -9.67. In the year 2005, what is the difference between the Exports(as % of merchandise exports) of Estonia and Exports(as % of merchandise exports) of Ghana?
Provide a succinct answer. 3.84. In the year 2005, what is the difference between the Exports(as % of merchandise exports) in Estonia and Exports(as % of merchandise exports) in Togo?
Ensure brevity in your answer.  5.97. In the year 2005, what is the difference between the Exports(as % of merchandise exports) in Estonia and Exports(as % of merchandise exports) in Tunisia?
Offer a very short reply. -5.73. In the year 2005, what is the difference between the Exports(as % of merchandise exports) of Ghana and Exports(as % of merchandise exports) of Togo?
Your response must be concise. 2.13. In the year 2005, what is the difference between the Exports(as % of merchandise exports) of Ghana and Exports(as % of merchandise exports) of Tunisia?
Provide a short and direct response. -9.58. In the year 2005, what is the difference between the Exports(as % of merchandise exports) of Togo and Exports(as % of merchandise exports) of Tunisia?
Ensure brevity in your answer.  -11.7. In the year 2007, what is the difference between the Exports(as % of merchandise exports) of Estonia and Exports(as % of merchandise exports) of Ghana?
Give a very brief answer. 11.03. In the year 2007, what is the difference between the Exports(as % of merchandise exports) of Estonia and Exports(as % of merchandise exports) of Togo?
Provide a short and direct response. 12.32. In the year 2007, what is the difference between the Exports(as % of merchandise exports) of Estonia and Exports(as % of merchandise exports) of Tunisia?
Offer a very short reply. -3.89. In the year 2007, what is the difference between the Exports(as % of merchandise exports) of Ghana and Exports(as % of merchandise exports) of Togo?
Make the answer very short. 1.29. In the year 2007, what is the difference between the Exports(as % of merchandise exports) of Ghana and Exports(as % of merchandise exports) of Tunisia?
Your response must be concise. -14.92. In the year 2007, what is the difference between the Exports(as % of merchandise exports) of Togo and Exports(as % of merchandise exports) of Tunisia?
Offer a terse response. -16.2. In the year 2008, what is the difference between the Exports(as % of merchandise exports) in Estonia and Exports(as % of merchandise exports) in Ghana?
Your answer should be very brief. 9.28. In the year 2008, what is the difference between the Exports(as % of merchandise exports) in Estonia and Exports(as % of merchandise exports) in Togo?
Keep it short and to the point. 3.76. In the year 2008, what is the difference between the Exports(as % of merchandise exports) in Estonia and Exports(as % of merchandise exports) in Tunisia?
Keep it short and to the point. -5.62. In the year 2008, what is the difference between the Exports(as % of merchandise exports) in Ghana and Exports(as % of merchandise exports) in Togo?
Keep it short and to the point. -5.52. In the year 2008, what is the difference between the Exports(as % of merchandise exports) of Ghana and Exports(as % of merchandise exports) of Tunisia?
Provide a succinct answer. -14.91. In the year 2008, what is the difference between the Exports(as % of merchandise exports) in Togo and Exports(as % of merchandise exports) in Tunisia?
Provide a short and direct response. -9.39. In the year 2009, what is the difference between the Exports(as % of merchandise exports) of Estonia and Exports(as % of merchandise exports) of Ghana?
Your response must be concise. 12.06. In the year 2009, what is the difference between the Exports(as % of merchandise exports) of Estonia and Exports(as % of merchandise exports) of Togo?
Offer a terse response. 16.21. In the year 2009, what is the difference between the Exports(as % of merchandise exports) in Estonia and Exports(as % of merchandise exports) in Tunisia?
Make the answer very short. 2.6. In the year 2009, what is the difference between the Exports(as % of merchandise exports) of Ghana and Exports(as % of merchandise exports) of Togo?
Make the answer very short. 4.15. In the year 2009, what is the difference between the Exports(as % of merchandise exports) in Ghana and Exports(as % of merchandise exports) in Tunisia?
Your answer should be very brief. -9.46. In the year 2009, what is the difference between the Exports(as % of merchandise exports) of Togo and Exports(as % of merchandise exports) of Tunisia?
Your answer should be compact. -13.6. What is the ratio of the Exports(as % of merchandise exports) of Estonia in 1998 to that in 2000?
Ensure brevity in your answer.  0.82. What is the ratio of the Exports(as % of merchandise exports) of Ghana in 1998 to that in 2000?
Your answer should be compact. 0.47. What is the ratio of the Exports(as % of merchandise exports) of Togo in 1998 to that in 2000?
Keep it short and to the point. 0.01. What is the ratio of the Exports(as % of merchandise exports) of Tunisia in 1998 to that in 2000?
Your response must be concise. 0.53. What is the ratio of the Exports(as % of merchandise exports) of Estonia in 1998 to that in 2001?
Your response must be concise. 0.94. What is the ratio of the Exports(as % of merchandise exports) in Ghana in 1998 to that in 2001?
Ensure brevity in your answer.  0.33. What is the ratio of the Exports(as % of merchandise exports) in Togo in 1998 to that in 2001?
Your answer should be very brief. 0.01. What is the ratio of the Exports(as % of merchandise exports) of Tunisia in 1998 to that in 2001?
Offer a very short reply. 0.7. What is the ratio of the Exports(as % of merchandise exports) in Estonia in 1998 to that in 2003?
Provide a succinct answer. 0.87. What is the ratio of the Exports(as % of merchandise exports) in Ghana in 1998 to that in 2003?
Your answer should be very brief. 64.13. What is the ratio of the Exports(as % of merchandise exports) of Togo in 1998 to that in 2003?
Provide a short and direct response. 0.01. What is the ratio of the Exports(as % of merchandise exports) of Tunisia in 1998 to that in 2003?
Offer a terse response. 0.64. What is the ratio of the Exports(as % of merchandise exports) in Estonia in 1998 to that in 2005?
Give a very brief answer. 0.51. What is the ratio of the Exports(as % of merchandise exports) of Ghana in 1998 to that in 2005?
Offer a very short reply. 1.08. What is the ratio of the Exports(as % of merchandise exports) of Togo in 1998 to that in 2005?
Make the answer very short. 0. What is the ratio of the Exports(as % of merchandise exports) of Tunisia in 1998 to that in 2005?
Make the answer very short. 0.5. What is the ratio of the Exports(as % of merchandise exports) in Estonia in 1998 to that in 2007?
Provide a short and direct response. 0.3. What is the ratio of the Exports(as % of merchandise exports) of Ghana in 1998 to that in 2007?
Make the answer very short. 2.82. What is the ratio of the Exports(as % of merchandise exports) in Togo in 1998 to that in 2007?
Provide a short and direct response. 0.84. What is the ratio of the Exports(as % of merchandise exports) in Tunisia in 1998 to that in 2007?
Your answer should be compact. 0.4. What is the ratio of the Exports(as % of merchandise exports) of Estonia in 1998 to that in 2008?
Your answer should be very brief. 0.31. What is the ratio of the Exports(as % of merchandise exports) in Ghana in 1998 to that in 2008?
Keep it short and to the point. 1.51. What is the ratio of the Exports(as % of merchandise exports) of Togo in 1998 to that in 2008?
Your answer should be compact. 0. What is the ratio of the Exports(as % of merchandise exports) in Tunisia in 1998 to that in 2008?
Give a very brief answer. 0.37. What is the ratio of the Exports(as % of merchandise exports) in Estonia in 1998 to that in 2009?
Provide a short and direct response. 0.23. What is the ratio of the Exports(as % of merchandise exports) of Ghana in 1998 to that in 2009?
Your answer should be very brief. 0.87. What is the ratio of the Exports(as % of merchandise exports) of Togo in 1998 to that in 2009?
Give a very brief answer. 0.12. What is the ratio of the Exports(as % of merchandise exports) in Tunisia in 1998 to that in 2009?
Give a very brief answer. 0.47. What is the ratio of the Exports(as % of merchandise exports) in Estonia in 2000 to that in 2001?
Provide a succinct answer. 1.14. What is the ratio of the Exports(as % of merchandise exports) of Ghana in 2000 to that in 2001?
Make the answer very short. 0.69. What is the ratio of the Exports(as % of merchandise exports) of Togo in 2000 to that in 2001?
Your answer should be very brief. 1.58. What is the ratio of the Exports(as % of merchandise exports) in Tunisia in 2000 to that in 2001?
Offer a very short reply. 1.31. What is the ratio of the Exports(as % of merchandise exports) of Estonia in 2000 to that in 2003?
Give a very brief answer. 1.06. What is the ratio of the Exports(as % of merchandise exports) in Ghana in 2000 to that in 2003?
Your answer should be compact. 135.93. What is the ratio of the Exports(as % of merchandise exports) in Togo in 2000 to that in 2003?
Make the answer very short. 1.87. What is the ratio of the Exports(as % of merchandise exports) of Tunisia in 2000 to that in 2003?
Offer a terse response. 1.21. What is the ratio of the Exports(as % of merchandise exports) in Estonia in 2000 to that in 2005?
Offer a terse response. 0.62. What is the ratio of the Exports(as % of merchandise exports) of Ghana in 2000 to that in 2005?
Make the answer very short. 2.29. What is the ratio of the Exports(as % of merchandise exports) of Togo in 2000 to that in 2005?
Your answer should be compact. 0.52. What is the ratio of the Exports(as % of merchandise exports) of Tunisia in 2000 to that in 2005?
Keep it short and to the point. 0.93. What is the ratio of the Exports(as % of merchandise exports) of Estonia in 2000 to that in 2007?
Offer a very short reply. 0.36. What is the ratio of the Exports(as % of merchandise exports) in Ghana in 2000 to that in 2007?
Your response must be concise. 5.98. What is the ratio of the Exports(as % of merchandise exports) of Togo in 2000 to that in 2007?
Provide a short and direct response. 130.61. What is the ratio of the Exports(as % of merchandise exports) of Tunisia in 2000 to that in 2007?
Offer a very short reply. 0.75. What is the ratio of the Exports(as % of merchandise exports) in Estonia in 2000 to that in 2008?
Make the answer very short. 0.38. What is the ratio of the Exports(as % of merchandise exports) in Ghana in 2000 to that in 2008?
Ensure brevity in your answer.  3.2. What is the ratio of the Exports(as % of merchandise exports) of Togo in 2000 to that in 2008?
Give a very brief answer. 0.08. What is the ratio of the Exports(as % of merchandise exports) of Tunisia in 2000 to that in 2008?
Your answer should be compact. 0.7. What is the ratio of the Exports(as % of merchandise exports) of Estonia in 2000 to that in 2009?
Offer a terse response. 0.28. What is the ratio of the Exports(as % of merchandise exports) in Ghana in 2000 to that in 2009?
Make the answer very short. 1.85. What is the ratio of the Exports(as % of merchandise exports) of Togo in 2000 to that in 2009?
Your answer should be compact. 18.06. What is the ratio of the Exports(as % of merchandise exports) of Tunisia in 2000 to that in 2009?
Provide a short and direct response. 0.89. What is the ratio of the Exports(as % of merchandise exports) of Estonia in 2001 to that in 2003?
Give a very brief answer. 0.93. What is the ratio of the Exports(as % of merchandise exports) in Ghana in 2001 to that in 2003?
Your answer should be compact. 196.17. What is the ratio of the Exports(as % of merchandise exports) of Togo in 2001 to that in 2003?
Ensure brevity in your answer.  1.18. What is the ratio of the Exports(as % of merchandise exports) of Tunisia in 2001 to that in 2003?
Offer a terse response. 0.92. What is the ratio of the Exports(as % of merchandise exports) in Estonia in 2001 to that in 2005?
Keep it short and to the point. 0.54. What is the ratio of the Exports(as % of merchandise exports) in Ghana in 2001 to that in 2005?
Offer a terse response. 3.3. What is the ratio of the Exports(as % of merchandise exports) in Togo in 2001 to that in 2005?
Your answer should be compact. 0.33. What is the ratio of the Exports(as % of merchandise exports) in Tunisia in 2001 to that in 2005?
Ensure brevity in your answer.  0.71. What is the ratio of the Exports(as % of merchandise exports) of Estonia in 2001 to that in 2007?
Your answer should be very brief. 0.32. What is the ratio of the Exports(as % of merchandise exports) of Ghana in 2001 to that in 2007?
Ensure brevity in your answer.  8.63. What is the ratio of the Exports(as % of merchandise exports) in Togo in 2001 to that in 2007?
Ensure brevity in your answer.  82.64. What is the ratio of the Exports(as % of merchandise exports) in Tunisia in 2001 to that in 2007?
Your response must be concise. 0.57. What is the ratio of the Exports(as % of merchandise exports) in Estonia in 2001 to that in 2008?
Your response must be concise. 0.33. What is the ratio of the Exports(as % of merchandise exports) of Ghana in 2001 to that in 2008?
Provide a short and direct response. 4.62. What is the ratio of the Exports(as % of merchandise exports) in Togo in 2001 to that in 2008?
Make the answer very short. 0.05. What is the ratio of the Exports(as % of merchandise exports) of Tunisia in 2001 to that in 2008?
Offer a very short reply. 0.53. What is the ratio of the Exports(as % of merchandise exports) in Estonia in 2001 to that in 2009?
Offer a very short reply. 0.24. What is the ratio of the Exports(as % of merchandise exports) of Ghana in 2001 to that in 2009?
Provide a succinct answer. 2.67. What is the ratio of the Exports(as % of merchandise exports) of Togo in 2001 to that in 2009?
Offer a very short reply. 11.43. What is the ratio of the Exports(as % of merchandise exports) of Tunisia in 2001 to that in 2009?
Give a very brief answer. 0.68. What is the ratio of the Exports(as % of merchandise exports) of Estonia in 2003 to that in 2005?
Your answer should be compact. 0.58. What is the ratio of the Exports(as % of merchandise exports) in Ghana in 2003 to that in 2005?
Ensure brevity in your answer.  0.02. What is the ratio of the Exports(as % of merchandise exports) of Togo in 2003 to that in 2005?
Provide a short and direct response. 0.28. What is the ratio of the Exports(as % of merchandise exports) of Tunisia in 2003 to that in 2005?
Offer a terse response. 0.77. What is the ratio of the Exports(as % of merchandise exports) of Estonia in 2003 to that in 2007?
Make the answer very short. 0.34. What is the ratio of the Exports(as % of merchandise exports) of Ghana in 2003 to that in 2007?
Provide a short and direct response. 0.04. What is the ratio of the Exports(as % of merchandise exports) of Togo in 2003 to that in 2007?
Your answer should be very brief. 69.93. What is the ratio of the Exports(as % of merchandise exports) in Tunisia in 2003 to that in 2007?
Provide a succinct answer. 0.62. What is the ratio of the Exports(as % of merchandise exports) in Estonia in 2003 to that in 2008?
Keep it short and to the point. 0.36. What is the ratio of the Exports(as % of merchandise exports) in Ghana in 2003 to that in 2008?
Make the answer very short. 0.02. What is the ratio of the Exports(as % of merchandise exports) in Togo in 2003 to that in 2008?
Provide a short and direct response. 0.04. What is the ratio of the Exports(as % of merchandise exports) of Tunisia in 2003 to that in 2008?
Keep it short and to the point. 0.58. What is the ratio of the Exports(as % of merchandise exports) of Estonia in 2003 to that in 2009?
Keep it short and to the point. 0.26. What is the ratio of the Exports(as % of merchandise exports) of Ghana in 2003 to that in 2009?
Give a very brief answer. 0.01. What is the ratio of the Exports(as % of merchandise exports) in Togo in 2003 to that in 2009?
Provide a short and direct response. 9.67. What is the ratio of the Exports(as % of merchandise exports) in Tunisia in 2003 to that in 2009?
Give a very brief answer. 0.73. What is the ratio of the Exports(as % of merchandise exports) of Estonia in 2005 to that in 2007?
Ensure brevity in your answer.  0.59. What is the ratio of the Exports(as % of merchandise exports) of Ghana in 2005 to that in 2007?
Offer a terse response. 2.61. What is the ratio of the Exports(as % of merchandise exports) in Togo in 2005 to that in 2007?
Offer a very short reply. 252.16. What is the ratio of the Exports(as % of merchandise exports) of Tunisia in 2005 to that in 2007?
Your response must be concise. 0.8. What is the ratio of the Exports(as % of merchandise exports) in Estonia in 2005 to that in 2008?
Give a very brief answer. 0.62. What is the ratio of the Exports(as % of merchandise exports) of Ghana in 2005 to that in 2008?
Make the answer very short. 1.4. What is the ratio of the Exports(as % of merchandise exports) of Togo in 2005 to that in 2008?
Ensure brevity in your answer.  0.16. What is the ratio of the Exports(as % of merchandise exports) in Tunisia in 2005 to that in 2008?
Your answer should be compact. 0.75. What is the ratio of the Exports(as % of merchandise exports) in Estonia in 2005 to that in 2009?
Make the answer very short. 0.44. What is the ratio of the Exports(as % of merchandise exports) of Ghana in 2005 to that in 2009?
Keep it short and to the point. 0.81. What is the ratio of the Exports(as % of merchandise exports) of Togo in 2005 to that in 2009?
Provide a short and direct response. 34.87. What is the ratio of the Exports(as % of merchandise exports) of Tunisia in 2005 to that in 2009?
Provide a short and direct response. 0.95. What is the ratio of the Exports(as % of merchandise exports) of Estonia in 2007 to that in 2008?
Offer a terse response. 1.05. What is the ratio of the Exports(as % of merchandise exports) in Ghana in 2007 to that in 2008?
Keep it short and to the point. 0.54. What is the ratio of the Exports(as % of merchandise exports) in Togo in 2007 to that in 2008?
Your response must be concise. 0. What is the ratio of the Exports(as % of merchandise exports) in Tunisia in 2007 to that in 2008?
Keep it short and to the point. 0.94. What is the ratio of the Exports(as % of merchandise exports) in Estonia in 2007 to that in 2009?
Provide a short and direct response. 0.76. What is the ratio of the Exports(as % of merchandise exports) of Ghana in 2007 to that in 2009?
Give a very brief answer. 0.31. What is the ratio of the Exports(as % of merchandise exports) of Togo in 2007 to that in 2009?
Your answer should be compact. 0.14. What is the ratio of the Exports(as % of merchandise exports) of Tunisia in 2007 to that in 2009?
Your answer should be very brief. 1.19. What is the ratio of the Exports(as % of merchandise exports) of Estonia in 2008 to that in 2009?
Your response must be concise. 0.72. What is the ratio of the Exports(as % of merchandise exports) in Ghana in 2008 to that in 2009?
Keep it short and to the point. 0.58. What is the ratio of the Exports(as % of merchandise exports) in Togo in 2008 to that in 2009?
Provide a short and direct response. 221.7. What is the ratio of the Exports(as % of merchandise exports) of Tunisia in 2008 to that in 2009?
Offer a terse response. 1.27. What is the difference between the highest and the second highest Exports(as % of merchandise exports) of Estonia?
Your answer should be very brief. 3.92. What is the difference between the highest and the second highest Exports(as % of merchandise exports) of Ghana?
Provide a short and direct response. 3.43. What is the difference between the highest and the second highest Exports(as % of merchandise exports) in Togo?
Keep it short and to the point. 6.69. What is the difference between the highest and the second highest Exports(as % of merchandise exports) of Tunisia?
Offer a very short reply. 1.12. What is the difference between the highest and the lowest Exports(as % of merchandise exports) of Estonia?
Provide a short and direct response. 12.56. What is the difference between the highest and the lowest Exports(as % of merchandise exports) of Ghana?
Provide a succinct answer. 11.1. What is the difference between the highest and the lowest Exports(as % of merchandise exports) in Togo?
Your response must be concise. 7.93. What is the difference between the highest and the lowest Exports(as % of merchandise exports) in Tunisia?
Your response must be concise. 10.89. 